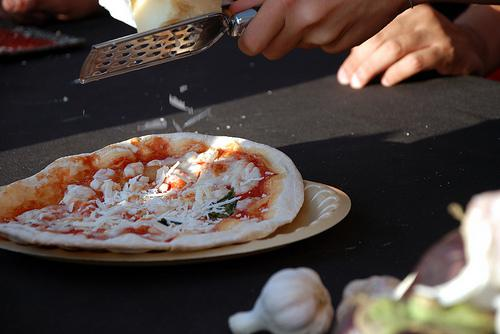Question: where is the plate?
Choices:
A. On the pizza box.
B. Under the pizza.
C. In the cupboard.
D. In the refrigerator.
Answer with the letter. Answer: B Question: where is the cheese?
Choices:
A. On the top shelve.
B. On the counter.
C. On the pizza.
D. Above the grate.
Answer with the letter. Answer: D Question: how is the weather?
Choices:
A. Sunny.
B. Rainy.
C. Snowy.
D. Cloudy.
Answer with the letter. Answer: A Question: what are the people doing?
Choices:
A. Chopping onions.
B. Washing dishes.
C. Painting a picture.
D. Grating cheese onto a pizza.
Answer with the letter. Answer: D 